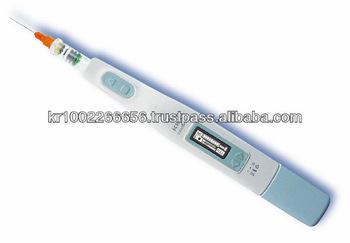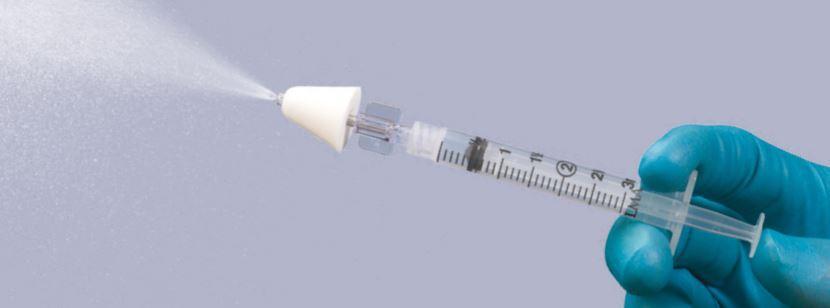The first image is the image on the left, the second image is the image on the right. Analyze the images presented: Is the assertion "There is at least one gloved hand in the picture." valid? Answer yes or no. Yes. 